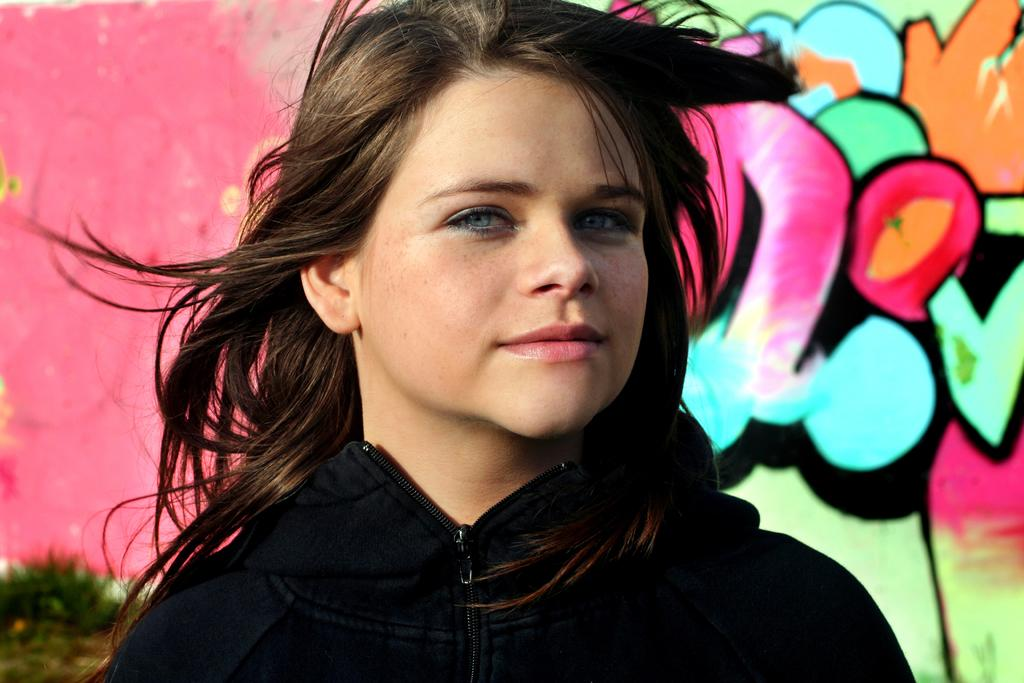Who is the main subject in the image? There is a girl in the center of the image. What can be seen in the background of the image? There is graffiti in the background of the image. Where is the kitty hiding in the image? There is no kitty present in the image. What trick is the girl performing in the image? The image does not depict the girl performing any tricks. 